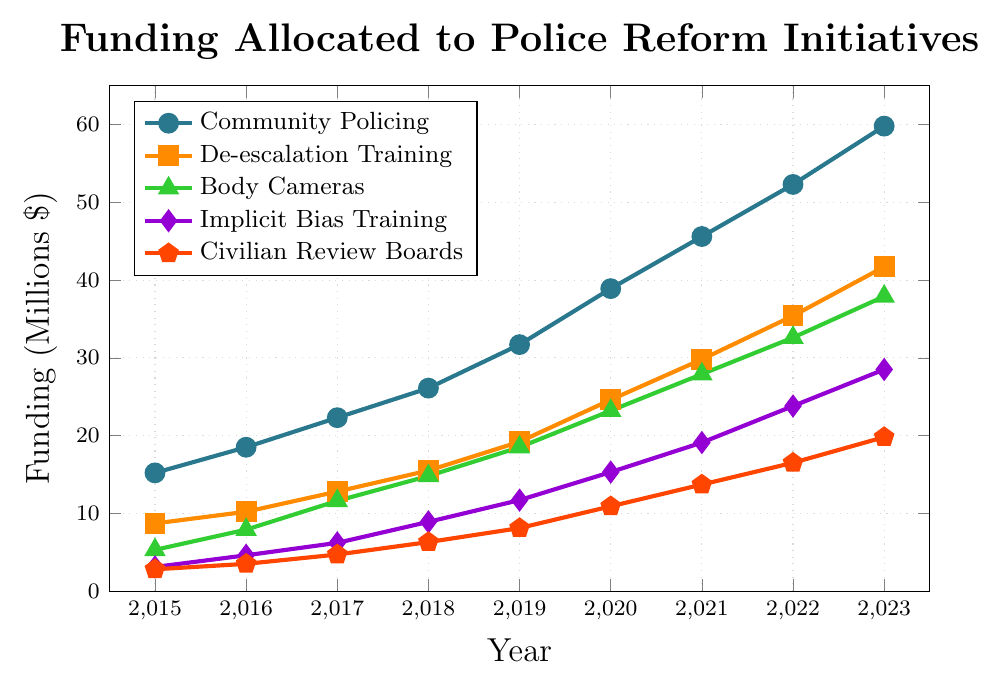What was the total funding allocated in 2019 for all program areas combined? Sum up the funding for each program area in 2019: 31.7 (Community Policing) + 19.2 (De-escalation Training) + 18.5 (Body Cameras) + 11.7 (Implicit Bias Training) + 8.1 (Civilian Review Boards). Total: 31.7 + 19.2 + 18.5 + 11.7 + 8.1 = 89.2
Answer: 89.2 Which program area had the highest funding in 2021? Look at the 2021 data points for each program area and identify the highest value. Community Policing has the highest funding at 45.6.
Answer: Community Policing Between 2015 and 2020, which program area had the largest increase in funding and by how much? Calculate the difference in funding from 2015 to 2020 for each program: 38.9 - 15.2 = 23.7 (Community Policing), 24.6 - 8.7 = 15.9 (De-escalation Training), 23.2 - 5.3 = 17.9 (Body Cameras), 15.3 - 3.1 = 12.2 (Implicit Bias Training), 10.9 - 2.8 = 8.1 (Civilian Review Boards). The largest increase is for Community Policing with an increase of 23.7.
Answer: Community Policing, 23.7 Compare the funding amounts for Body Cameras and Implicit Bias Training in 2017. Which had more funding and by how much? The funding amount for Body Cameras in 2017 is 11.6, and for Implicit Bias Training, it's 6.2. Subtract 6.2 from 11.6 to find the difference: 11.6 - 6.2 = 5.4. Body Cameras had more funding by 5.4.
Answer: Body Cameras, 5.4 What's the average annual increase in funding for Civilian Review Boards from 2015 to 2023? Calculate the total increase over the period: 19.8 (2023) - 2.8 (2015) = 17. Divide this by the number of years (2023-2015 = 8) to find the average annual increase: 17 / 8 = 2.125.
Answer: 2.125 In which year did De-escalation Training funding surpass 20 million dollars? Identify the year when De-escalation Training funding first exceeds 20 million dollars from the data points: The funding surpassed 20 million dollars in 2020 with 24.6 million.
Answer: 2020 What is the trend in funding for Implicit Bias Training from 2015 to 2023? Observe the data points for Implicit Bias Training from 2015 to 2023: The funding consistently increases each year, from 3.1 in 2015 to 28.5 in 2023.
Answer: Increasing trend What is the combined funding for Body Cameras and De-escalation Training in 2023? Add the funding amounts for Body Cameras and De-escalation Training in 2023: 37.9 (Body Cameras) + 41.7 (De-escalation Training) = 79.6.
Answer: 79.6 Which program had the lowest funding in 2015 and how much was it? Look at the 2015 funding amounts for each program area and identify the lowest value. Civilian Review Boards had the lowest funding at 2.8.
Answer: Civilian Review Boards, 2.8 How much more funding was allocated to Community Policing compared to Civilian Review Boards in 2022? Subtract the funding amount for Civilian Review Boards from Community Policing in 2022: 52.3 (Community Policing) - 16.5 (Civilian Review Boards) = 35.8.
Answer: 35.8 